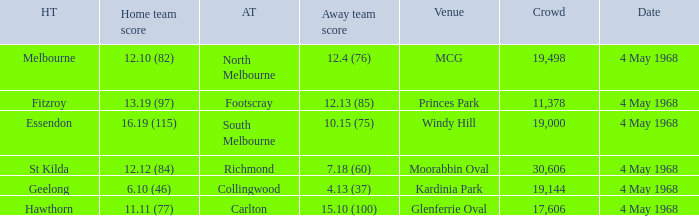How big was the crowd of the team that scored 4.13 (37)? 19144.0. 